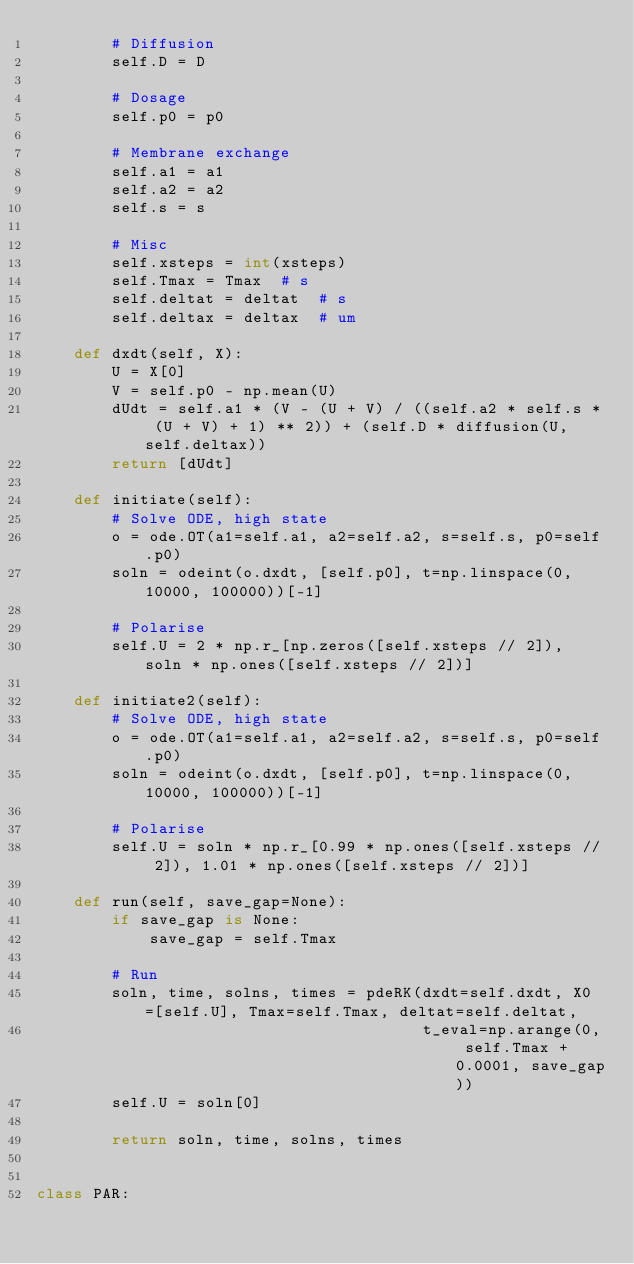Convert code to text. <code><loc_0><loc_0><loc_500><loc_500><_Python_>        # Diffusion
        self.D = D

        # Dosage
        self.p0 = p0

        # Membrane exchange
        self.a1 = a1
        self.a2 = a2
        self.s = s

        # Misc
        self.xsteps = int(xsteps)
        self.Tmax = Tmax  # s
        self.deltat = deltat  # s
        self.deltax = deltax  # um

    def dxdt(self, X):
        U = X[0]
        V = self.p0 - np.mean(U)
        dUdt = self.a1 * (V - (U + V) / ((self.a2 * self.s * (U + V) + 1) ** 2)) + (self.D * diffusion(U, self.deltax))
        return [dUdt]

    def initiate(self):
        # Solve ODE, high state
        o = ode.OT(a1=self.a1, a2=self.a2, s=self.s, p0=self.p0)
        soln = odeint(o.dxdt, [self.p0], t=np.linspace(0, 10000, 100000))[-1]

        # Polarise
        self.U = 2 * np.r_[np.zeros([self.xsteps // 2]), soln * np.ones([self.xsteps // 2])]

    def initiate2(self):
        # Solve ODE, high state
        o = ode.OT(a1=self.a1, a2=self.a2, s=self.s, p0=self.p0)
        soln = odeint(o.dxdt, [self.p0], t=np.linspace(0, 10000, 100000))[-1]

        # Polarise
        self.U = soln * np.r_[0.99 * np.ones([self.xsteps // 2]), 1.01 * np.ones([self.xsteps // 2])]

    def run(self, save_gap=None):
        if save_gap is None:
            save_gap = self.Tmax

        # Run
        soln, time, solns, times = pdeRK(dxdt=self.dxdt, X0=[self.U], Tmax=self.Tmax, deltat=self.deltat,
                                         t_eval=np.arange(0, self.Tmax + 0.0001, save_gap))
        self.U = soln[0]

        return soln, time, solns, times


class PAR:</code> 